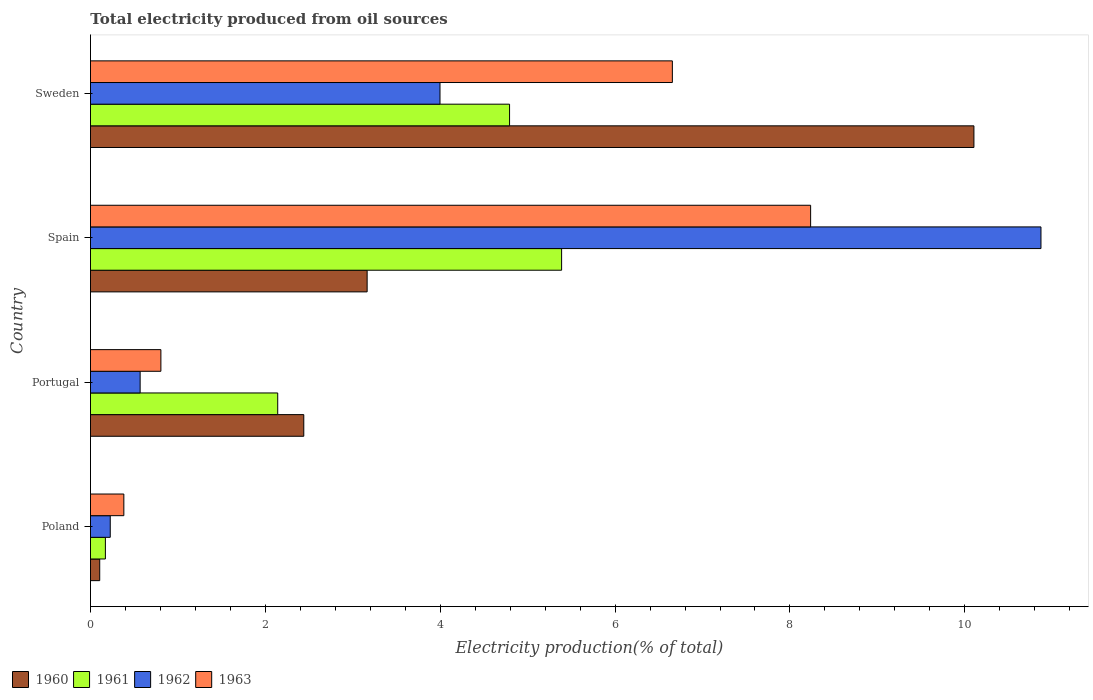How many groups of bars are there?
Your response must be concise. 4. Are the number of bars per tick equal to the number of legend labels?
Offer a very short reply. Yes. Are the number of bars on each tick of the Y-axis equal?
Keep it short and to the point. Yes. How many bars are there on the 2nd tick from the top?
Give a very brief answer. 4. How many bars are there on the 3rd tick from the bottom?
Give a very brief answer. 4. In how many cases, is the number of bars for a given country not equal to the number of legend labels?
Keep it short and to the point. 0. What is the total electricity produced in 1961 in Poland?
Make the answer very short. 0.17. Across all countries, what is the maximum total electricity produced in 1962?
Offer a terse response. 10.87. Across all countries, what is the minimum total electricity produced in 1963?
Provide a short and direct response. 0.38. What is the total total electricity produced in 1960 in the graph?
Offer a terse response. 15.81. What is the difference between the total electricity produced in 1960 in Poland and that in Sweden?
Your answer should be very brief. -10. What is the difference between the total electricity produced in 1963 in Poland and the total electricity produced in 1960 in Sweden?
Offer a very short reply. -9.72. What is the average total electricity produced in 1960 per country?
Ensure brevity in your answer.  3.95. What is the difference between the total electricity produced in 1961 and total electricity produced in 1960 in Sweden?
Make the answer very short. -5.31. What is the ratio of the total electricity produced in 1961 in Portugal to that in Spain?
Your response must be concise. 0.4. Is the difference between the total electricity produced in 1961 in Poland and Portugal greater than the difference between the total electricity produced in 1960 in Poland and Portugal?
Provide a succinct answer. Yes. What is the difference between the highest and the second highest total electricity produced in 1962?
Ensure brevity in your answer.  6.87. What is the difference between the highest and the lowest total electricity produced in 1963?
Ensure brevity in your answer.  7.85. In how many countries, is the total electricity produced in 1961 greater than the average total electricity produced in 1961 taken over all countries?
Provide a short and direct response. 2. Is it the case that in every country, the sum of the total electricity produced in 1961 and total electricity produced in 1963 is greater than the sum of total electricity produced in 1960 and total electricity produced in 1962?
Offer a very short reply. No. What does the 3rd bar from the top in Sweden represents?
Give a very brief answer. 1961. What does the 2nd bar from the bottom in Sweden represents?
Provide a succinct answer. 1961. Are all the bars in the graph horizontal?
Offer a very short reply. Yes. Does the graph contain any zero values?
Offer a very short reply. No. Does the graph contain grids?
Offer a very short reply. No. Where does the legend appear in the graph?
Give a very brief answer. Bottom left. What is the title of the graph?
Keep it short and to the point. Total electricity produced from oil sources. Does "1988" appear as one of the legend labels in the graph?
Offer a terse response. No. What is the Electricity production(% of total) in 1960 in Poland?
Provide a short and direct response. 0.11. What is the Electricity production(% of total) in 1961 in Poland?
Your response must be concise. 0.17. What is the Electricity production(% of total) of 1962 in Poland?
Ensure brevity in your answer.  0.23. What is the Electricity production(% of total) of 1963 in Poland?
Provide a short and direct response. 0.38. What is the Electricity production(% of total) of 1960 in Portugal?
Offer a terse response. 2.44. What is the Electricity production(% of total) of 1961 in Portugal?
Provide a short and direct response. 2.14. What is the Electricity production(% of total) in 1962 in Portugal?
Offer a very short reply. 0.57. What is the Electricity production(% of total) of 1963 in Portugal?
Your answer should be very brief. 0.81. What is the Electricity production(% of total) in 1960 in Spain?
Your response must be concise. 3.16. What is the Electricity production(% of total) of 1961 in Spain?
Offer a terse response. 5.39. What is the Electricity production(% of total) of 1962 in Spain?
Keep it short and to the point. 10.87. What is the Electricity production(% of total) in 1963 in Spain?
Keep it short and to the point. 8.24. What is the Electricity production(% of total) in 1960 in Sweden?
Offer a terse response. 10.1. What is the Electricity production(% of total) in 1961 in Sweden?
Your answer should be very brief. 4.79. What is the Electricity production(% of total) in 1962 in Sweden?
Your answer should be compact. 4. What is the Electricity production(% of total) of 1963 in Sweden?
Your answer should be very brief. 6.66. Across all countries, what is the maximum Electricity production(% of total) in 1960?
Your answer should be very brief. 10.1. Across all countries, what is the maximum Electricity production(% of total) of 1961?
Provide a short and direct response. 5.39. Across all countries, what is the maximum Electricity production(% of total) of 1962?
Your answer should be compact. 10.87. Across all countries, what is the maximum Electricity production(% of total) of 1963?
Provide a short and direct response. 8.24. Across all countries, what is the minimum Electricity production(% of total) in 1960?
Give a very brief answer. 0.11. Across all countries, what is the minimum Electricity production(% of total) of 1961?
Offer a very short reply. 0.17. Across all countries, what is the minimum Electricity production(% of total) of 1962?
Offer a very short reply. 0.23. Across all countries, what is the minimum Electricity production(% of total) in 1963?
Give a very brief answer. 0.38. What is the total Electricity production(% of total) of 1960 in the graph?
Make the answer very short. 15.81. What is the total Electricity production(% of total) of 1961 in the graph?
Give a very brief answer. 12.49. What is the total Electricity production(% of total) in 1962 in the graph?
Provide a short and direct response. 15.66. What is the total Electricity production(% of total) in 1963 in the graph?
Ensure brevity in your answer.  16.08. What is the difference between the Electricity production(% of total) of 1960 in Poland and that in Portugal?
Your answer should be very brief. -2.33. What is the difference between the Electricity production(% of total) of 1961 in Poland and that in Portugal?
Offer a terse response. -1.97. What is the difference between the Electricity production(% of total) of 1962 in Poland and that in Portugal?
Your response must be concise. -0.34. What is the difference between the Electricity production(% of total) in 1963 in Poland and that in Portugal?
Provide a succinct answer. -0.42. What is the difference between the Electricity production(% of total) of 1960 in Poland and that in Spain?
Keep it short and to the point. -3.06. What is the difference between the Electricity production(% of total) in 1961 in Poland and that in Spain?
Your answer should be very brief. -5.22. What is the difference between the Electricity production(% of total) in 1962 in Poland and that in Spain?
Offer a terse response. -10.64. What is the difference between the Electricity production(% of total) of 1963 in Poland and that in Spain?
Your answer should be very brief. -7.85. What is the difference between the Electricity production(% of total) of 1960 in Poland and that in Sweden?
Make the answer very short. -10. What is the difference between the Electricity production(% of total) of 1961 in Poland and that in Sweden?
Offer a very short reply. -4.62. What is the difference between the Electricity production(% of total) of 1962 in Poland and that in Sweden?
Your answer should be very brief. -3.77. What is the difference between the Electricity production(% of total) of 1963 in Poland and that in Sweden?
Your response must be concise. -6.27. What is the difference between the Electricity production(% of total) in 1960 in Portugal and that in Spain?
Provide a succinct answer. -0.72. What is the difference between the Electricity production(% of total) in 1961 in Portugal and that in Spain?
Keep it short and to the point. -3.25. What is the difference between the Electricity production(% of total) in 1962 in Portugal and that in Spain?
Give a very brief answer. -10.3. What is the difference between the Electricity production(% of total) in 1963 in Portugal and that in Spain?
Make the answer very short. -7.43. What is the difference between the Electricity production(% of total) of 1960 in Portugal and that in Sweden?
Provide a short and direct response. -7.66. What is the difference between the Electricity production(% of total) in 1961 in Portugal and that in Sweden?
Keep it short and to the point. -2.65. What is the difference between the Electricity production(% of total) of 1962 in Portugal and that in Sweden?
Give a very brief answer. -3.43. What is the difference between the Electricity production(% of total) in 1963 in Portugal and that in Sweden?
Make the answer very short. -5.85. What is the difference between the Electricity production(% of total) in 1960 in Spain and that in Sweden?
Your response must be concise. -6.94. What is the difference between the Electricity production(% of total) of 1961 in Spain and that in Sweden?
Keep it short and to the point. 0.6. What is the difference between the Electricity production(% of total) of 1962 in Spain and that in Sweden?
Make the answer very short. 6.87. What is the difference between the Electricity production(% of total) of 1963 in Spain and that in Sweden?
Offer a very short reply. 1.58. What is the difference between the Electricity production(% of total) in 1960 in Poland and the Electricity production(% of total) in 1961 in Portugal?
Your response must be concise. -2.04. What is the difference between the Electricity production(% of total) in 1960 in Poland and the Electricity production(% of total) in 1962 in Portugal?
Give a very brief answer. -0.46. What is the difference between the Electricity production(% of total) of 1960 in Poland and the Electricity production(% of total) of 1963 in Portugal?
Your answer should be compact. -0.7. What is the difference between the Electricity production(% of total) of 1961 in Poland and the Electricity production(% of total) of 1962 in Portugal?
Provide a succinct answer. -0.4. What is the difference between the Electricity production(% of total) of 1961 in Poland and the Electricity production(% of total) of 1963 in Portugal?
Offer a terse response. -0.63. What is the difference between the Electricity production(% of total) of 1962 in Poland and the Electricity production(% of total) of 1963 in Portugal?
Keep it short and to the point. -0.58. What is the difference between the Electricity production(% of total) of 1960 in Poland and the Electricity production(% of total) of 1961 in Spain?
Provide a succinct answer. -5.28. What is the difference between the Electricity production(% of total) of 1960 in Poland and the Electricity production(% of total) of 1962 in Spain?
Ensure brevity in your answer.  -10.77. What is the difference between the Electricity production(% of total) of 1960 in Poland and the Electricity production(% of total) of 1963 in Spain?
Your answer should be compact. -8.13. What is the difference between the Electricity production(% of total) of 1961 in Poland and the Electricity production(% of total) of 1962 in Spain?
Your response must be concise. -10.7. What is the difference between the Electricity production(% of total) of 1961 in Poland and the Electricity production(% of total) of 1963 in Spain?
Your response must be concise. -8.07. What is the difference between the Electricity production(% of total) of 1962 in Poland and the Electricity production(% of total) of 1963 in Spain?
Offer a terse response. -8.01. What is the difference between the Electricity production(% of total) of 1960 in Poland and the Electricity production(% of total) of 1961 in Sweden?
Ensure brevity in your answer.  -4.69. What is the difference between the Electricity production(% of total) in 1960 in Poland and the Electricity production(% of total) in 1962 in Sweden?
Offer a terse response. -3.89. What is the difference between the Electricity production(% of total) of 1960 in Poland and the Electricity production(% of total) of 1963 in Sweden?
Provide a short and direct response. -6.55. What is the difference between the Electricity production(% of total) of 1961 in Poland and the Electricity production(% of total) of 1962 in Sweden?
Ensure brevity in your answer.  -3.83. What is the difference between the Electricity production(% of total) of 1961 in Poland and the Electricity production(% of total) of 1963 in Sweden?
Offer a terse response. -6.48. What is the difference between the Electricity production(% of total) in 1962 in Poland and the Electricity production(% of total) in 1963 in Sweden?
Your answer should be compact. -6.43. What is the difference between the Electricity production(% of total) of 1960 in Portugal and the Electricity production(% of total) of 1961 in Spain?
Your answer should be very brief. -2.95. What is the difference between the Electricity production(% of total) of 1960 in Portugal and the Electricity production(% of total) of 1962 in Spain?
Ensure brevity in your answer.  -8.43. What is the difference between the Electricity production(% of total) of 1960 in Portugal and the Electricity production(% of total) of 1963 in Spain?
Offer a terse response. -5.8. What is the difference between the Electricity production(% of total) of 1961 in Portugal and the Electricity production(% of total) of 1962 in Spain?
Your answer should be very brief. -8.73. What is the difference between the Electricity production(% of total) of 1961 in Portugal and the Electricity production(% of total) of 1963 in Spain?
Give a very brief answer. -6.09. What is the difference between the Electricity production(% of total) of 1962 in Portugal and the Electricity production(% of total) of 1963 in Spain?
Offer a very short reply. -7.67. What is the difference between the Electricity production(% of total) of 1960 in Portugal and the Electricity production(% of total) of 1961 in Sweden?
Provide a short and direct response. -2.35. What is the difference between the Electricity production(% of total) of 1960 in Portugal and the Electricity production(% of total) of 1962 in Sweden?
Your answer should be compact. -1.56. What is the difference between the Electricity production(% of total) of 1960 in Portugal and the Electricity production(% of total) of 1963 in Sweden?
Provide a short and direct response. -4.22. What is the difference between the Electricity production(% of total) of 1961 in Portugal and the Electricity production(% of total) of 1962 in Sweden?
Your answer should be very brief. -1.86. What is the difference between the Electricity production(% of total) of 1961 in Portugal and the Electricity production(% of total) of 1963 in Sweden?
Provide a succinct answer. -4.51. What is the difference between the Electricity production(% of total) in 1962 in Portugal and the Electricity production(% of total) in 1963 in Sweden?
Your answer should be very brief. -6.09. What is the difference between the Electricity production(% of total) in 1960 in Spain and the Electricity production(% of total) in 1961 in Sweden?
Offer a very short reply. -1.63. What is the difference between the Electricity production(% of total) in 1960 in Spain and the Electricity production(% of total) in 1962 in Sweden?
Make the answer very short. -0.83. What is the difference between the Electricity production(% of total) of 1960 in Spain and the Electricity production(% of total) of 1963 in Sweden?
Your response must be concise. -3.49. What is the difference between the Electricity production(% of total) in 1961 in Spain and the Electricity production(% of total) in 1962 in Sweden?
Offer a very short reply. 1.39. What is the difference between the Electricity production(% of total) of 1961 in Spain and the Electricity production(% of total) of 1963 in Sweden?
Provide a short and direct response. -1.27. What is the difference between the Electricity production(% of total) of 1962 in Spain and the Electricity production(% of total) of 1963 in Sweden?
Your answer should be very brief. 4.22. What is the average Electricity production(% of total) of 1960 per country?
Your answer should be very brief. 3.95. What is the average Electricity production(% of total) of 1961 per country?
Give a very brief answer. 3.12. What is the average Electricity production(% of total) of 1962 per country?
Offer a very short reply. 3.92. What is the average Electricity production(% of total) in 1963 per country?
Offer a very short reply. 4.02. What is the difference between the Electricity production(% of total) of 1960 and Electricity production(% of total) of 1961 in Poland?
Your answer should be very brief. -0.06. What is the difference between the Electricity production(% of total) in 1960 and Electricity production(% of total) in 1962 in Poland?
Your answer should be very brief. -0.12. What is the difference between the Electricity production(% of total) of 1960 and Electricity production(% of total) of 1963 in Poland?
Offer a terse response. -0.28. What is the difference between the Electricity production(% of total) in 1961 and Electricity production(% of total) in 1962 in Poland?
Keep it short and to the point. -0.06. What is the difference between the Electricity production(% of total) of 1961 and Electricity production(% of total) of 1963 in Poland?
Your answer should be compact. -0.21. What is the difference between the Electricity production(% of total) in 1962 and Electricity production(% of total) in 1963 in Poland?
Provide a short and direct response. -0.16. What is the difference between the Electricity production(% of total) in 1960 and Electricity production(% of total) in 1961 in Portugal?
Give a very brief answer. 0.3. What is the difference between the Electricity production(% of total) of 1960 and Electricity production(% of total) of 1962 in Portugal?
Make the answer very short. 1.87. What is the difference between the Electricity production(% of total) in 1960 and Electricity production(% of total) in 1963 in Portugal?
Your answer should be very brief. 1.63. What is the difference between the Electricity production(% of total) in 1961 and Electricity production(% of total) in 1962 in Portugal?
Provide a short and direct response. 1.57. What is the difference between the Electricity production(% of total) of 1961 and Electricity production(% of total) of 1963 in Portugal?
Give a very brief answer. 1.34. What is the difference between the Electricity production(% of total) of 1962 and Electricity production(% of total) of 1963 in Portugal?
Offer a very short reply. -0.24. What is the difference between the Electricity production(% of total) in 1960 and Electricity production(% of total) in 1961 in Spain?
Your answer should be compact. -2.22. What is the difference between the Electricity production(% of total) of 1960 and Electricity production(% of total) of 1962 in Spain?
Ensure brevity in your answer.  -7.71. What is the difference between the Electricity production(% of total) of 1960 and Electricity production(% of total) of 1963 in Spain?
Offer a terse response. -5.07. What is the difference between the Electricity production(% of total) in 1961 and Electricity production(% of total) in 1962 in Spain?
Your answer should be compact. -5.48. What is the difference between the Electricity production(% of total) in 1961 and Electricity production(% of total) in 1963 in Spain?
Keep it short and to the point. -2.85. What is the difference between the Electricity production(% of total) of 1962 and Electricity production(% of total) of 1963 in Spain?
Offer a terse response. 2.63. What is the difference between the Electricity production(% of total) in 1960 and Electricity production(% of total) in 1961 in Sweden?
Offer a terse response. 5.31. What is the difference between the Electricity production(% of total) in 1960 and Electricity production(% of total) in 1962 in Sweden?
Keep it short and to the point. 6.11. What is the difference between the Electricity production(% of total) of 1960 and Electricity production(% of total) of 1963 in Sweden?
Offer a very short reply. 3.45. What is the difference between the Electricity production(% of total) in 1961 and Electricity production(% of total) in 1962 in Sweden?
Ensure brevity in your answer.  0.8. What is the difference between the Electricity production(% of total) of 1961 and Electricity production(% of total) of 1963 in Sweden?
Provide a succinct answer. -1.86. What is the difference between the Electricity production(% of total) of 1962 and Electricity production(% of total) of 1963 in Sweden?
Offer a very short reply. -2.66. What is the ratio of the Electricity production(% of total) in 1960 in Poland to that in Portugal?
Provide a succinct answer. 0.04. What is the ratio of the Electricity production(% of total) in 1961 in Poland to that in Portugal?
Make the answer very short. 0.08. What is the ratio of the Electricity production(% of total) in 1962 in Poland to that in Portugal?
Your answer should be very brief. 0.4. What is the ratio of the Electricity production(% of total) in 1963 in Poland to that in Portugal?
Your answer should be very brief. 0.47. What is the ratio of the Electricity production(% of total) in 1960 in Poland to that in Spain?
Offer a terse response. 0.03. What is the ratio of the Electricity production(% of total) in 1961 in Poland to that in Spain?
Offer a very short reply. 0.03. What is the ratio of the Electricity production(% of total) in 1962 in Poland to that in Spain?
Keep it short and to the point. 0.02. What is the ratio of the Electricity production(% of total) of 1963 in Poland to that in Spain?
Your answer should be compact. 0.05. What is the ratio of the Electricity production(% of total) in 1960 in Poland to that in Sweden?
Offer a very short reply. 0.01. What is the ratio of the Electricity production(% of total) in 1961 in Poland to that in Sweden?
Provide a short and direct response. 0.04. What is the ratio of the Electricity production(% of total) of 1962 in Poland to that in Sweden?
Provide a short and direct response. 0.06. What is the ratio of the Electricity production(% of total) of 1963 in Poland to that in Sweden?
Offer a very short reply. 0.06. What is the ratio of the Electricity production(% of total) of 1960 in Portugal to that in Spain?
Offer a terse response. 0.77. What is the ratio of the Electricity production(% of total) in 1961 in Portugal to that in Spain?
Provide a succinct answer. 0.4. What is the ratio of the Electricity production(% of total) in 1962 in Portugal to that in Spain?
Provide a short and direct response. 0.05. What is the ratio of the Electricity production(% of total) in 1963 in Portugal to that in Spain?
Give a very brief answer. 0.1. What is the ratio of the Electricity production(% of total) in 1960 in Portugal to that in Sweden?
Ensure brevity in your answer.  0.24. What is the ratio of the Electricity production(% of total) of 1961 in Portugal to that in Sweden?
Make the answer very short. 0.45. What is the ratio of the Electricity production(% of total) in 1962 in Portugal to that in Sweden?
Ensure brevity in your answer.  0.14. What is the ratio of the Electricity production(% of total) in 1963 in Portugal to that in Sweden?
Your answer should be compact. 0.12. What is the ratio of the Electricity production(% of total) in 1960 in Spain to that in Sweden?
Offer a very short reply. 0.31. What is the ratio of the Electricity production(% of total) in 1961 in Spain to that in Sweden?
Offer a terse response. 1.12. What is the ratio of the Electricity production(% of total) of 1962 in Spain to that in Sweden?
Your response must be concise. 2.72. What is the ratio of the Electricity production(% of total) of 1963 in Spain to that in Sweden?
Provide a short and direct response. 1.24. What is the difference between the highest and the second highest Electricity production(% of total) in 1960?
Give a very brief answer. 6.94. What is the difference between the highest and the second highest Electricity production(% of total) in 1961?
Offer a very short reply. 0.6. What is the difference between the highest and the second highest Electricity production(% of total) in 1962?
Provide a short and direct response. 6.87. What is the difference between the highest and the second highest Electricity production(% of total) in 1963?
Ensure brevity in your answer.  1.58. What is the difference between the highest and the lowest Electricity production(% of total) of 1960?
Provide a succinct answer. 10. What is the difference between the highest and the lowest Electricity production(% of total) of 1961?
Give a very brief answer. 5.22. What is the difference between the highest and the lowest Electricity production(% of total) of 1962?
Keep it short and to the point. 10.64. What is the difference between the highest and the lowest Electricity production(% of total) of 1963?
Your answer should be very brief. 7.85. 